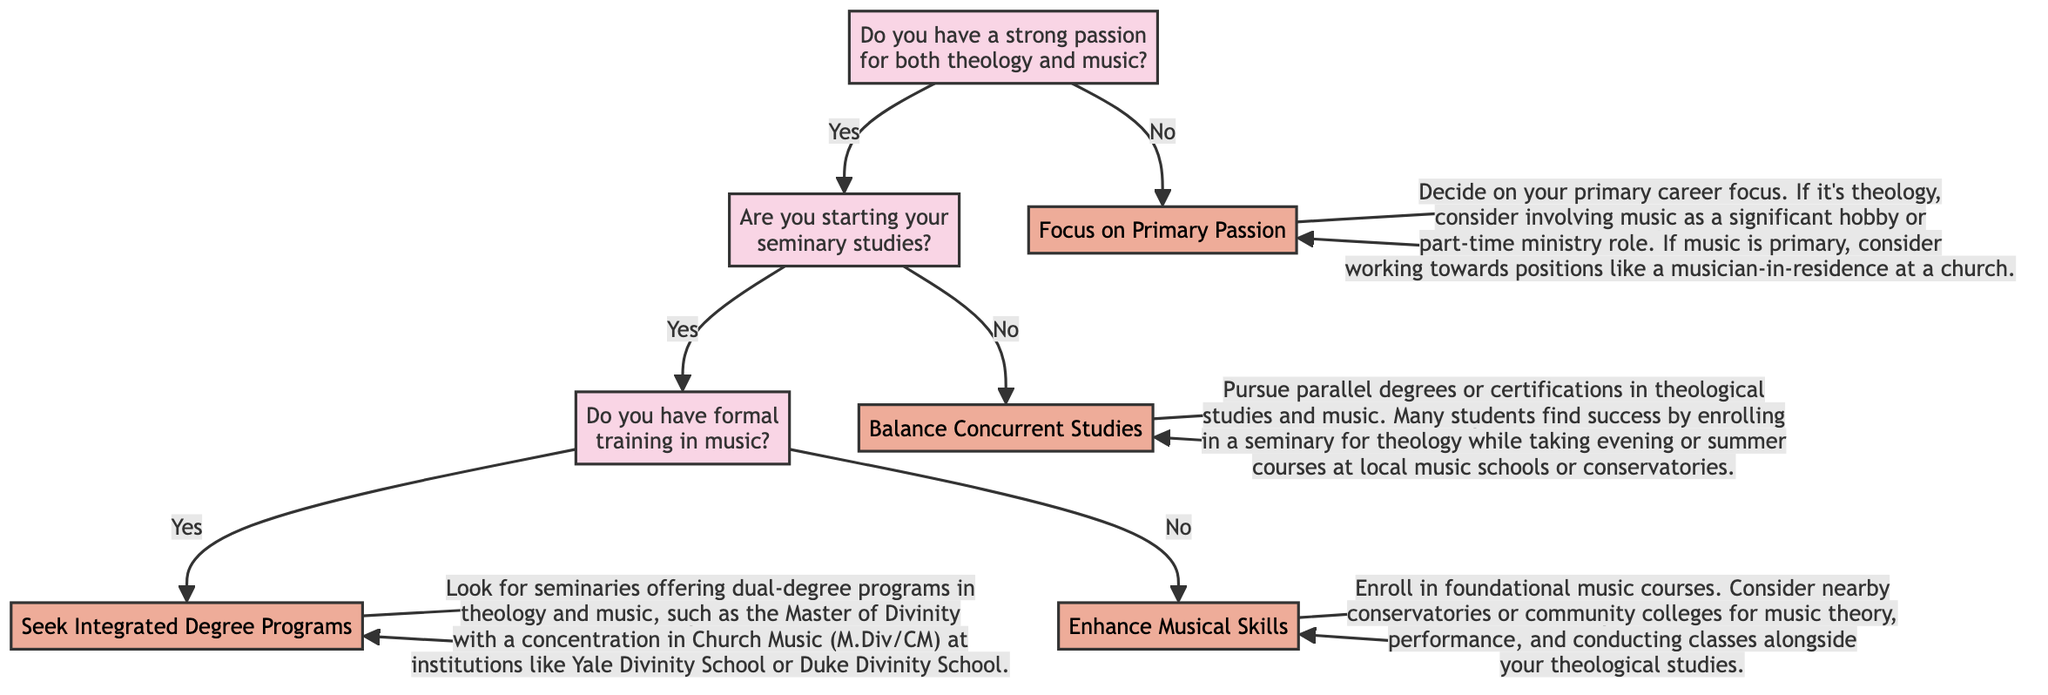How many pathways are described in the diagram? The diagram outlines four distinct pathways: Seek Integrated Degree Programs, Enhance Musical Skills, Balance Concurrent Studies, and Focus on Primary Passion. Each of these pathways emerges from different decision points in the tree.
Answer: 4 What is the first question in the decision tree? The first question in the decision tree is, "Do you have a strong passion for both theology and music?" This sets the stage for the subsequent branches based on the answer provided.
Answer: Do you have a strong passion for both theology and music? If someone answers "No" to the first question, what is their next step? If the answer to the first question is "No", the decision leads directly to the pathway "Focus on Primary Passion," which suggests the individual should decide on their primary career focus without further inquiries.
Answer: Focus on Primary Passion How does having formal training in music impact the decision? If an individual has formal training in music, the diagram directs them to "Seek Integrated Degree Programs," indicating that prior training opens up opportunities for specialized dual-degree programs in theology and music.
Answer: Seek Integrated Degree Programs What happens if a person is not starting seminary studies and has a strong passion for both fields? If a person has a strong passion for both theology and music but is not starting their seminary studies, they are advised to "Balance Concurrent Studies," allowing them to pursue theological studies in parallel with music courses.
Answer: Balance Concurrent Studies Explain the pathway if someone starts seminary studies but lacks formal music training. Starting with the answer "Yes" to beginning seminary studies but answering "No" to having formal music training leads to the pathway "Enhance Musical Skills." This suggests that they should enroll in foundational music courses to build their skills while studying theology.
Answer: Enhance Musical Skills 